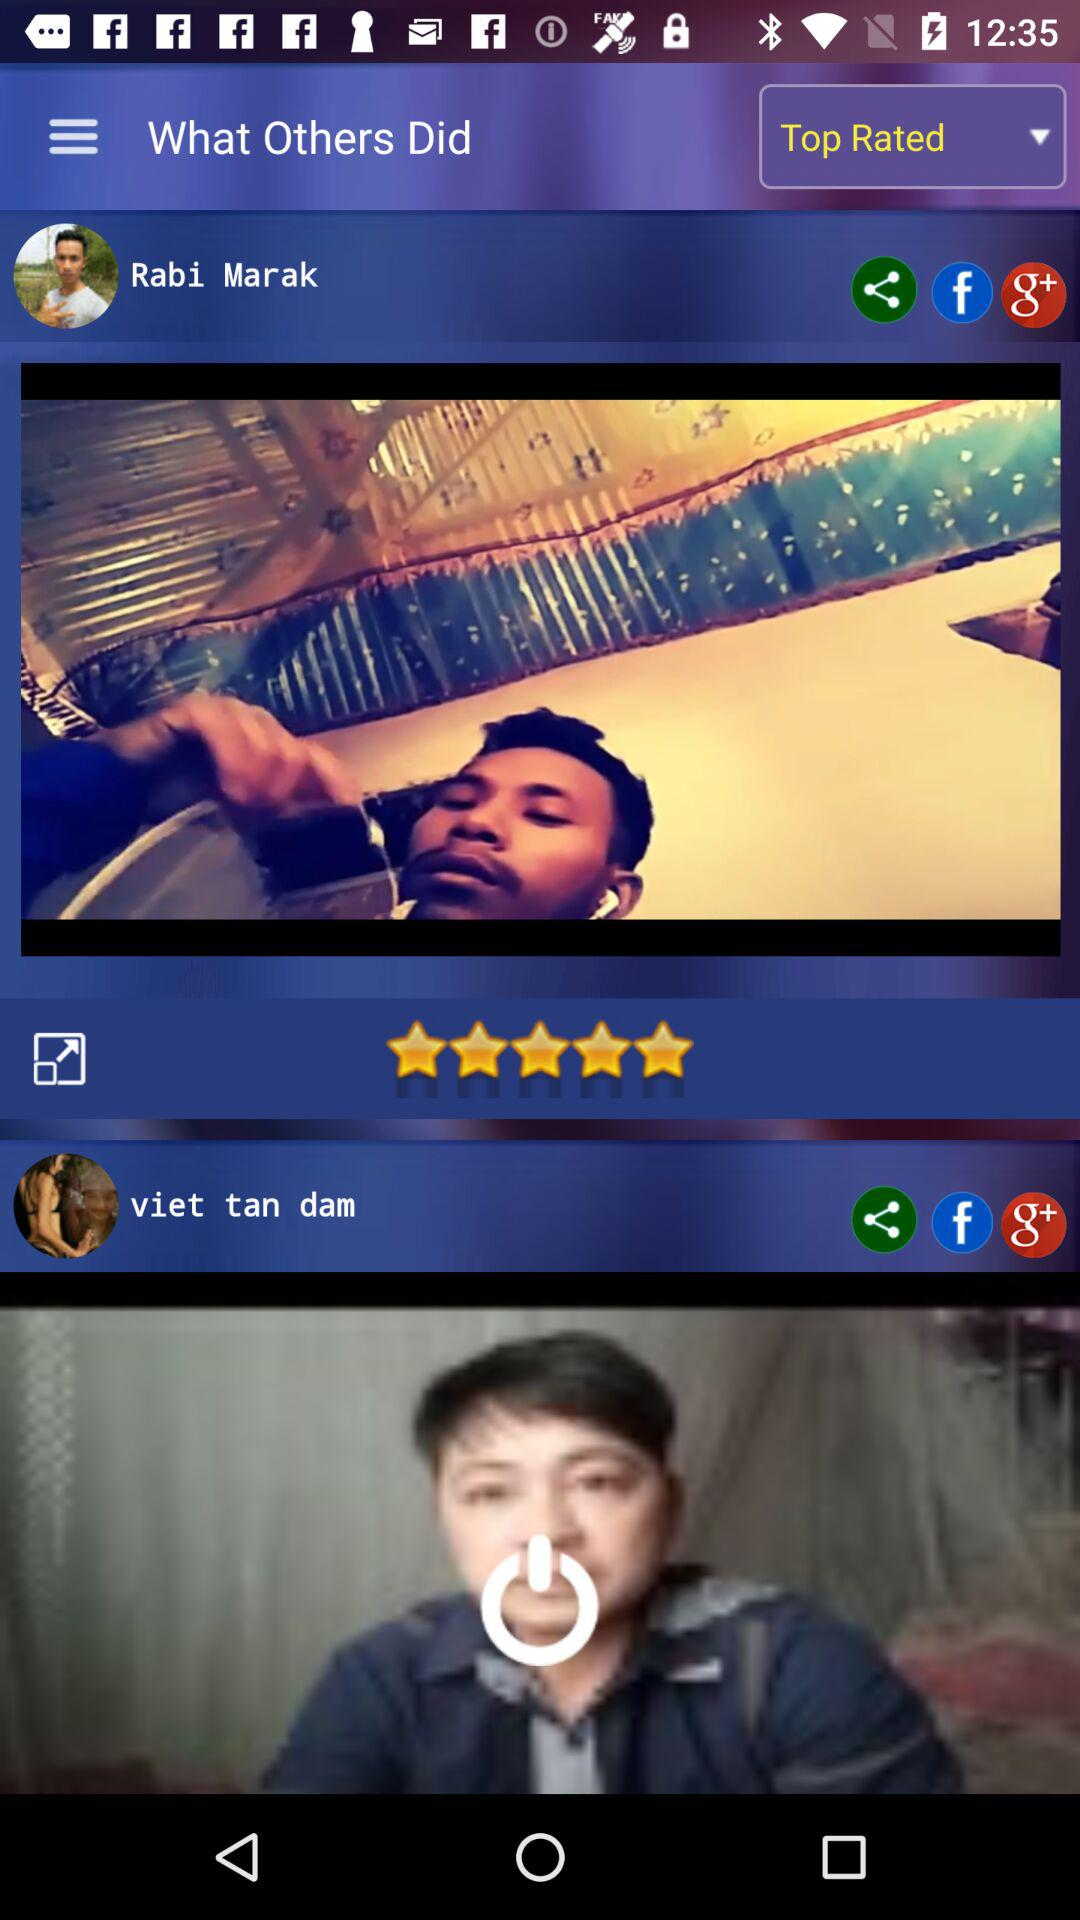What are the given ratings? The given rating is 5 stars. 